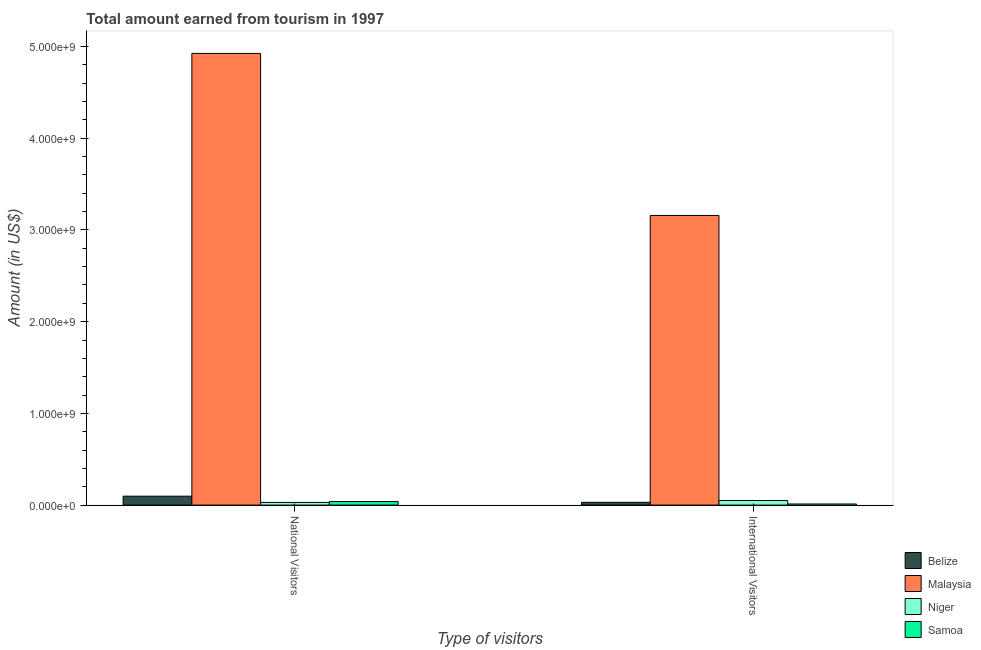Are the number of bars per tick equal to the number of legend labels?
Offer a terse response. Yes. Are the number of bars on each tick of the X-axis equal?
Offer a very short reply. Yes. What is the label of the 2nd group of bars from the left?
Provide a short and direct response. International Visitors. What is the amount earned from national visitors in Niger?
Ensure brevity in your answer.  2.90e+07. Across all countries, what is the maximum amount earned from international visitors?
Keep it short and to the point. 3.16e+09. Across all countries, what is the minimum amount earned from national visitors?
Offer a terse response. 2.90e+07. In which country was the amount earned from international visitors maximum?
Keep it short and to the point. Malaysia. In which country was the amount earned from national visitors minimum?
Your response must be concise. Niger. What is the total amount earned from national visitors in the graph?
Offer a very short reply. 5.09e+09. What is the difference between the amount earned from national visitors in Belize and that in Niger?
Offer a very short reply. 6.80e+07. What is the difference between the amount earned from national visitors in Malaysia and the amount earned from international visitors in Samoa?
Offer a terse response. 4.91e+09. What is the average amount earned from international visitors per country?
Your answer should be compact. 8.12e+08. What is the difference between the amount earned from international visitors and amount earned from national visitors in Belize?
Your answer should be compact. -6.70e+07. What is the ratio of the amount earned from national visitors in Malaysia to that in Samoa?
Keep it short and to the point. 127.88. What does the 4th bar from the left in International Visitors represents?
Keep it short and to the point. Samoa. What does the 1st bar from the right in International Visitors represents?
Provide a short and direct response. Samoa. How many bars are there?
Make the answer very short. 8. Are all the bars in the graph horizontal?
Provide a succinct answer. No. Where does the legend appear in the graph?
Provide a succinct answer. Bottom right. How many legend labels are there?
Keep it short and to the point. 4. How are the legend labels stacked?
Provide a short and direct response. Vertical. What is the title of the graph?
Your answer should be compact. Total amount earned from tourism in 1997. What is the label or title of the X-axis?
Provide a succinct answer. Type of visitors. What is the label or title of the Y-axis?
Your response must be concise. Amount (in US$). What is the Amount (in US$) of Belize in National Visitors?
Your response must be concise. 9.70e+07. What is the Amount (in US$) in Malaysia in National Visitors?
Ensure brevity in your answer.  4.92e+09. What is the Amount (in US$) of Niger in National Visitors?
Offer a terse response. 2.90e+07. What is the Amount (in US$) of Samoa in National Visitors?
Offer a very short reply. 3.85e+07. What is the Amount (in US$) of Belize in International Visitors?
Your answer should be very brief. 3.00e+07. What is the Amount (in US$) of Malaysia in International Visitors?
Offer a very short reply. 3.16e+09. What is the Amount (in US$) in Samoa in International Visitors?
Give a very brief answer. 1.20e+07. Across all Type of visitors, what is the maximum Amount (in US$) in Belize?
Your answer should be compact. 9.70e+07. Across all Type of visitors, what is the maximum Amount (in US$) in Malaysia?
Your response must be concise. 4.92e+09. Across all Type of visitors, what is the maximum Amount (in US$) in Niger?
Provide a short and direct response. 5.00e+07. Across all Type of visitors, what is the maximum Amount (in US$) in Samoa?
Provide a short and direct response. 3.85e+07. Across all Type of visitors, what is the minimum Amount (in US$) of Belize?
Give a very brief answer. 3.00e+07. Across all Type of visitors, what is the minimum Amount (in US$) in Malaysia?
Ensure brevity in your answer.  3.16e+09. Across all Type of visitors, what is the minimum Amount (in US$) of Niger?
Your answer should be compact. 2.90e+07. What is the total Amount (in US$) of Belize in the graph?
Offer a very short reply. 1.27e+08. What is the total Amount (in US$) of Malaysia in the graph?
Give a very brief answer. 8.08e+09. What is the total Amount (in US$) of Niger in the graph?
Ensure brevity in your answer.  7.90e+07. What is the total Amount (in US$) in Samoa in the graph?
Ensure brevity in your answer.  5.05e+07. What is the difference between the Amount (in US$) of Belize in National Visitors and that in International Visitors?
Your response must be concise. 6.70e+07. What is the difference between the Amount (in US$) of Malaysia in National Visitors and that in International Visitors?
Offer a very short reply. 1.77e+09. What is the difference between the Amount (in US$) of Niger in National Visitors and that in International Visitors?
Your answer should be compact. -2.10e+07. What is the difference between the Amount (in US$) in Samoa in National Visitors and that in International Visitors?
Your answer should be compact. 2.65e+07. What is the difference between the Amount (in US$) of Belize in National Visitors and the Amount (in US$) of Malaysia in International Visitors?
Keep it short and to the point. -3.06e+09. What is the difference between the Amount (in US$) in Belize in National Visitors and the Amount (in US$) in Niger in International Visitors?
Provide a succinct answer. 4.70e+07. What is the difference between the Amount (in US$) of Belize in National Visitors and the Amount (in US$) of Samoa in International Visitors?
Make the answer very short. 8.50e+07. What is the difference between the Amount (in US$) in Malaysia in National Visitors and the Amount (in US$) in Niger in International Visitors?
Offer a very short reply. 4.88e+09. What is the difference between the Amount (in US$) of Malaysia in National Visitors and the Amount (in US$) of Samoa in International Visitors?
Keep it short and to the point. 4.91e+09. What is the difference between the Amount (in US$) in Niger in National Visitors and the Amount (in US$) in Samoa in International Visitors?
Offer a very short reply. 1.70e+07. What is the average Amount (in US$) in Belize per Type of visitors?
Ensure brevity in your answer.  6.35e+07. What is the average Amount (in US$) of Malaysia per Type of visitors?
Your answer should be very brief. 4.04e+09. What is the average Amount (in US$) of Niger per Type of visitors?
Make the answer very short. 3.95e+07. What is the average Amount (in US$) in Samoa per Type of visitors?
Ensure brevity in your answer.  2.53e+07. What is the difference between the Amount (in US$) of Belize and Amount (in US$) of Malaysia in National Visitors?
Provide a succinct answer. -4.83e+09. What is the difference between the Amount (in US$) in Belize and Amount (in US$) in Niger in National Visitors?
Keep it short and to the point. 6.80e+07. What is the difference between the Amount (in US$) in Belize and Amount (in US$) in Samoa in National Visitors?
Offer a very short reply. 5.85e+07. What is the difference between the Amount (in US$) in Malaysia and Amount (in US$) in Niger in National Visitors?
Ensure brevity in your answer.  4.90e+09. What is the difference between the Amount (in US$) of Malaysia and Amount (in US$) of Samoa in National Visitors?
Offer a very short reply. 4.89e+09. What is the difference between the Amount (in US$) in Niger and Amount (in US$) in Samoa in National Visitors?
Offer a terse response. -9.51e+06. What is the difference between the Amount (in US$) of Belize and Amount (in US$) of Malaysia in International Visitors?
Make the answer very short. -3.13e+09. What is the difference between the Amount (in US$) of Belize and Amount (in US$) of Niger in International Visitors?
Provide a short and direct response. -2.00e+07. What is the difference between the Amount (in US$) of Belize and Amount (in US$) of Samoa in International Visitors?
Provide a short and direct response. 1.80e+07. What is the difference between the Amount (in US$) of Malaysia and Amount (in US$) of Niger in International Visitors?
Your answer should be compact. 3.11e+09. What is the difference between the Amount (in US$) of Malaysia and Amount (in US$) of Samoa in International Visitors?
Ensure brevity in your answer.  3.15e+09. What is the difference between the Amount (in US$) in Niger and Amount (in US$) in Samoa in International Visitors?
Keep it short and to the point. 3.80e+07. What is the ratio of the Amount (in US$) in Belize in National Visitors to that in International Visitors?
Provide a short and direct response. 3.23. What is the ratio of the Amount (in US$) in Malaysia in National Visitors to that in International Visitors?
Make the answer very short. 1.56. What is the ratio of the Amount (in US$) of Niger in National Visitors to that in International Visitors?
Give a very brief answer. 0.58. What is the ratio of the Amount (in US$) of Samoa in National Visitors to that in International Visitors?
Keep it short and to the point. 3.21. What is the difference between the highest and the second highest Amount (in US$) in Belize?
Ensure brevity in your answer.  6.70e+07. What is the difference between the highest and the second highest Amount (in US$) of Malaysia?
Your answer should be compact. 1.77e+09. What is the difference between the highest and the second highest Amount (in US$) in Niger?
Provide a succinct answer. 2.10e+07. What is the difference between the highest and the second highest Amount (in US$) in Samoa?
Give a very brief answer. 2.65e+07. What is the difference between the highest and the lowest Amount (in US$) in Belize?
Your answer should be compact. 6.70e+07. What is the difference between the highest and the lowest Amount (in US$) of Malaysia?
Give a very brief answer. 1.77e+09. What is the difference between the highest and the lowest Amount (in US$) of Niger?
Make the answer very short. 2.10e+07. What is the difference between the highest and the lowest Amount (in US$) in Samoa?
Make the answer very short. 2.65e+07. 